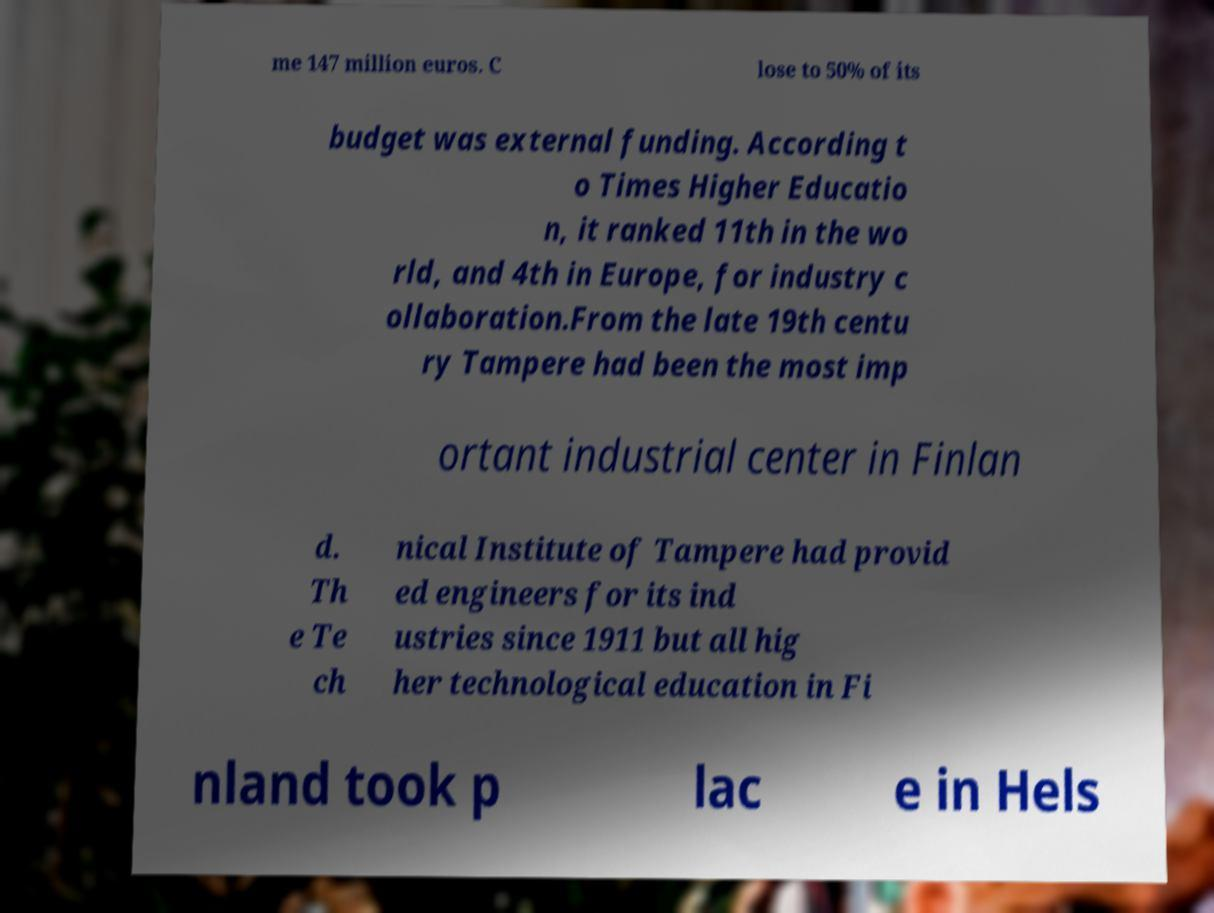Please identify and transcribe the text found in this image. me 147 million euros. C lose to 50% of its budget was external funding. According t o Times Higher Educatio n, it ranked 11th in the wo rld, and 4th in Europe, for industry c ollaboration.From the late 19th centu ry Tampere had been the most imp ortant industrial center in Finlan d. Th e Te ch nical Institute of Tampere had provid ed engineers for its ind ustries since 1911 but all hig her technological education in Fi nland took p lac e in Hels 